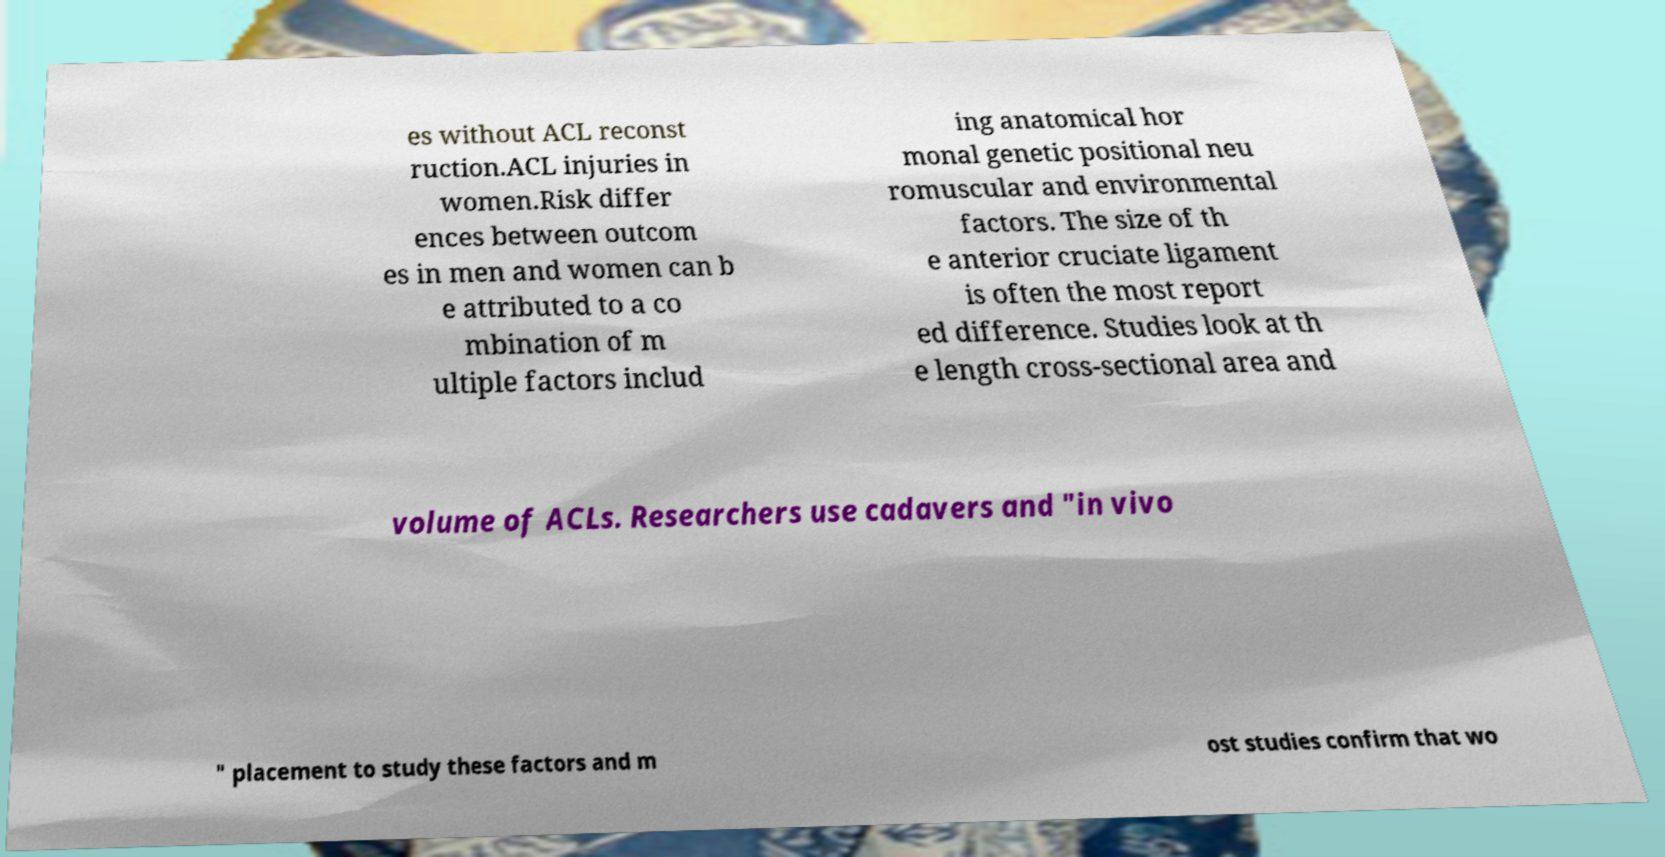What messages or text are displayed in this image? I need them in a readable, typed format. es without ACL reconst ruction.ACL injuries in women.Risk differ ences between outcom es in men and women can b e attributed to a co mbination of m ultiple factors includ ing anatomical hor monal genetic positional neu romuscular and environmental factors. The size of th e anterior cruciate ligament is often the most report ed difference. Studies look at th e length cross-sectional area and volume of ACLs. Researchers use cadavers and "in vivo " placement to study these factors and m ost studies confirm that wo 